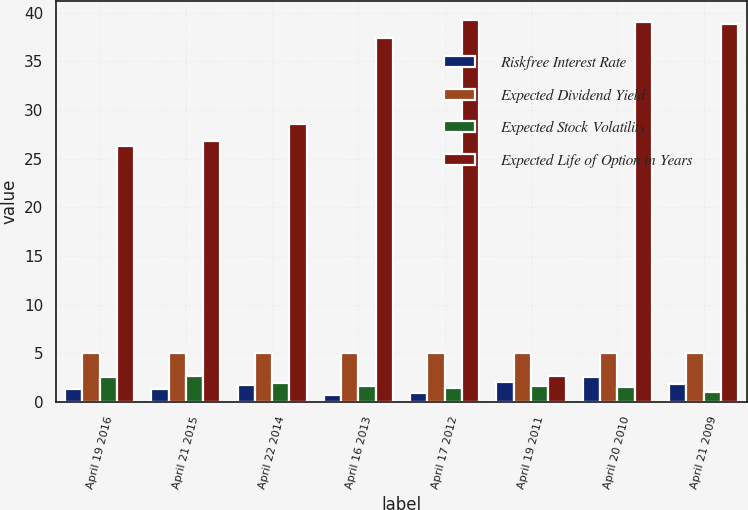Convert chart to OTSL. <chart><loc_0><loc_0><loc_500><loc_500><stacked_bar_chart><ecel><fcel>April 19 2016<fcel>April 21 2015<fcel>April 22 2014<fcel>April 16 2013<fcel>April 17 2012<fcel>April 19 2011<fcel>April 20 2010<fcel>April 21 2009<nl><fcel>Riskfree Interest Rate<fcel>1.3<fcel>1.3<fcel>1.8<fcel>0.7<fcel>0.9<fcel>2.1<fcel>2.6<fcel>1.9<nl><fcel>Expected Dividend Yield<fcel>5<fcel>5<fcel>5<fcel>5<fcel>5<fcel>5<fcel>5<fcel>5<nl><fcel>Expected Stock Volatility<fcel>2.6<fcel>2.7<fcel>2<fcel>1.6<fcel>1.4<fcel>1.6<fcel>1.5<fcel>1<nl><fcel>Expected Life of Option in Years<fcel>26.34<fcel>26.84<fcel>28.55<fcel>37.42<fcel>39.25<fcel>2.7<fcel>39.1<fcel>38.8<nl></chart> 